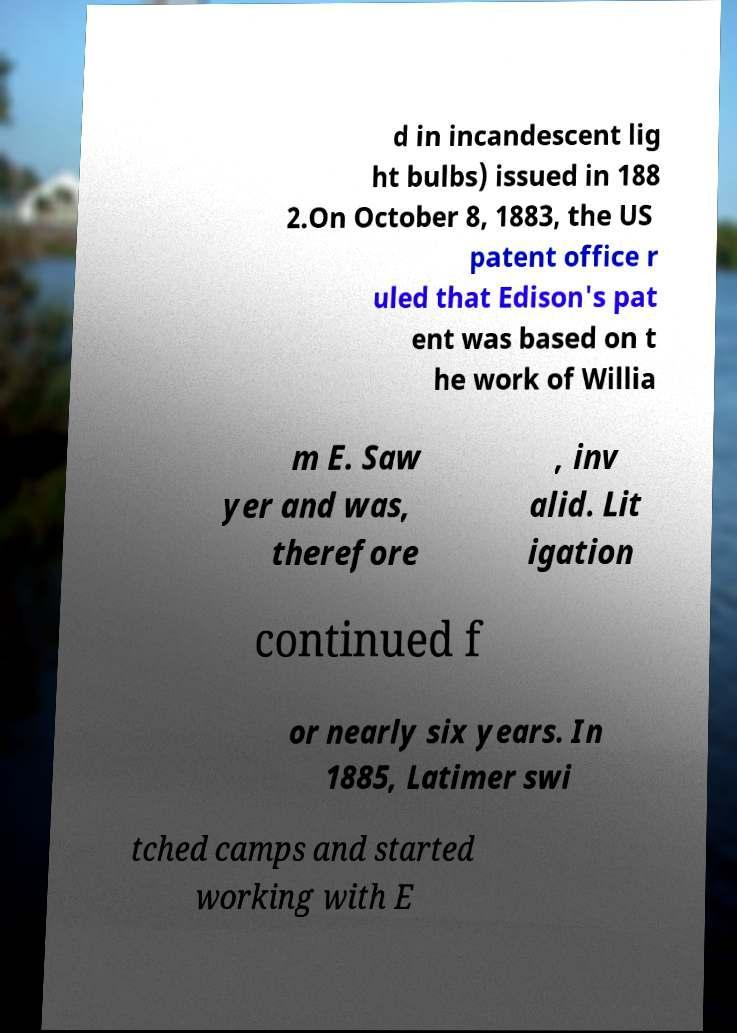Could you extract and type out the text from this image? d in incandescent lig ht bulbs) issued in 188 2.On October 8, 1883, the US patent office r uled that Edison's pat ent was based on t he work of Willia m E. Saw yer and was, therefore , inv alid. Lit igation continued f or nearly six years. In 1885, Latimer swi tched camps and started working with E 